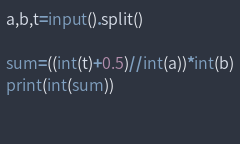<code> <loc_0><loc_0><loc_500><loc_500><_Python_>a,b,t=input().split()

sum=((int(t)+0.5)//int(a))*int(b)
print(int(sum))

  </code> 